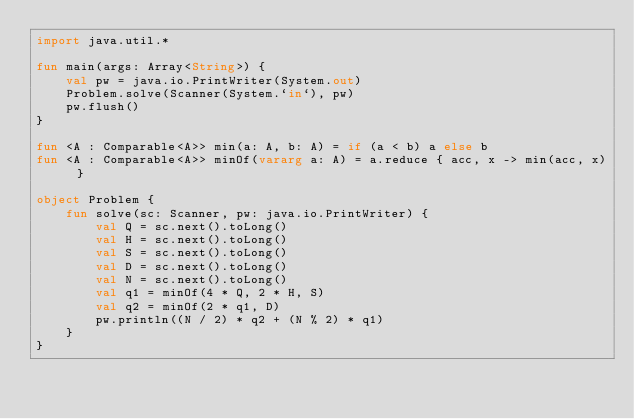Convert code to text. <code><loc_0><loc_0><loc_500><loc_500><_Kotlin_>import java.util.*

fun main(args: Array<String>) {
    val pw = java.io.PrintWriter(System.out)
    Problem.solve(Scanner(System.`in`), pw)
    pw.flush()
}

fun <A : Comparable<A>> min(a: A, b: A) = if (a < b) a else b
fun <A : Comparable<A>> minOf(vararg a: A) = a.reduce { acc, x -> min(acc, x) }

object Problem {
    fun solve(sc: Scanner, pw: java.io.PrintWriter) {
        val Q = sc.next().toLong()
        val H = sc.next().toLong()
        val S = sc.next().toLong()
        val D = sc.next().toLong()
        val N = sc.next().toLong()
        val q1 = minOf(4 * Q, 2 * H, S)
        val q2 = minOf(2 * q1, D)
        pw.println((N / 2) * q2 + (N % 2) * q1)
    }
}
</code> 